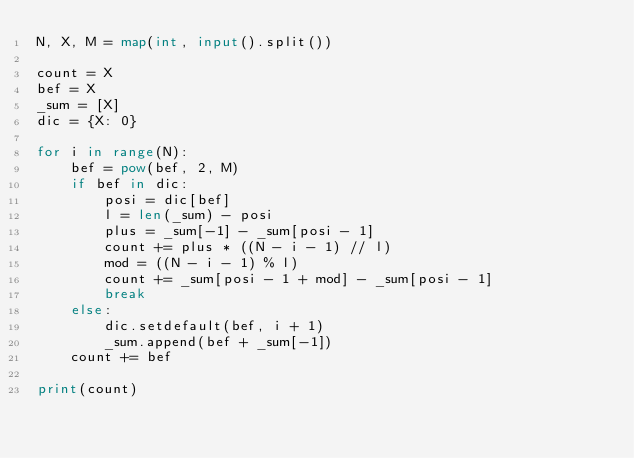Convert code to text. <code><loc_0><loc_0><loc_500><loc_500><_Python_>N, X, M = map(int, input().split())

count = X
bef = X
_sum = [X]
dic = {X: 0}

for i in range(N):
    bef = pow(bef, 2, M)
    if bef in dic:
        posi = dic[bef]
        l = len(_sum) - posi
        plus = _sum[-1] - _sum[posi - 1]
        count += plus * ((N - i - 1) // l)
        mod = ((N - i - 1) % l)
        count += _sum[posi - 1 + mod] - _sum[posi - 1]
        break
    else:
        dic.setdefault(bef, i + 1)
        _sum.append(bef + _sum[-1])
    count += bef

print(count)</code> 